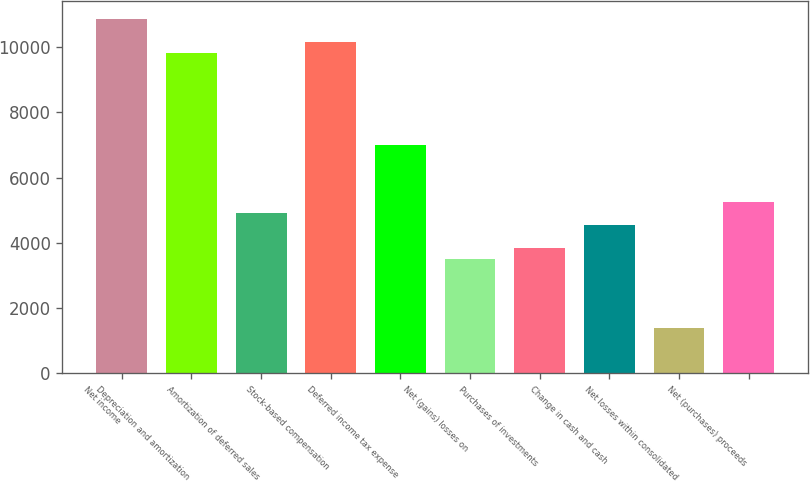Convert chart to OTSL. <chart><loc_0><loc_0><loc_500><loc_500><bar_chart><fcel>Net income<fcel>Depreciation and amortization<fcel>Amortization of deferred sales<fcel>Stock-based compensation<fcel>Deferred income tax expense<fcel>Net (gains) losses on<fcel>Purchases of investments<fcel>Change in cash and cash<fcel>Net losses within consolidated<fcel>Net (purchases) proceeds<nl><fcel>10864.4<fcel>9813.2<fcel>4907.6<fcel>10163.6<fcel>7010<fcel>3506<fcel>3856.4<fcel>4557.2<fcel>1403.6<fcel>5258<nl></chart> 